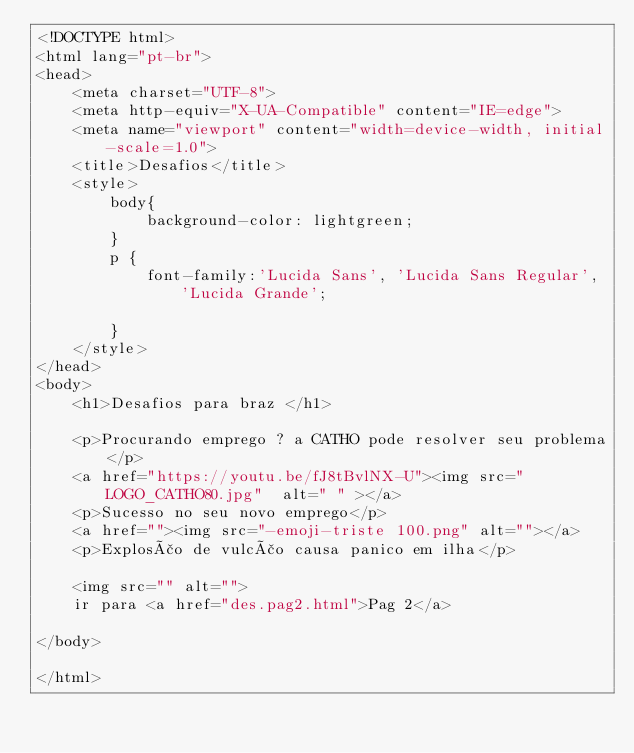<code> <loc_0><loc_0><loc_500><loc_500><_HTML_><!DOCTYPE html>
<html lang="pt-br">
<head>
    <meta charset="UTF-8">
    <meta http-equiv="X-UA-Compatible" content="IE=edge">
    <meta name="viewport" content="width=device-width, initial-scale=1.0">
    <title>Desafios</title>
    <style>
        body{
            background-color: lightgreen;
        }
        p {
            font-family:'Lucida Sans', 'Lucida Sans Regular', 'Lucida Grande';
            
        }
    </style>
</head>
<body>
    <h1>Desafios para braz </h1>

    <p>Procurando emprego ? a CATHO pode resolver seu problema</p>
    <a href="https://youtu.be/fJ8tBvlNX-U"><img src="LOGO_CATHO80.jpg"  alt=" " ></a>
    <p>Sucesso no seu novo emprego</p>
    <a href=""><img src="-emoji-triste 100.png" alt=""></a>
    <p>Explosão de vulcão causa panico em ilha</p>
                 
    <img src="" alt="">    
    ir para <a href="des.pag2.html">Pag 2</a>
  
</body>

</html></code> 